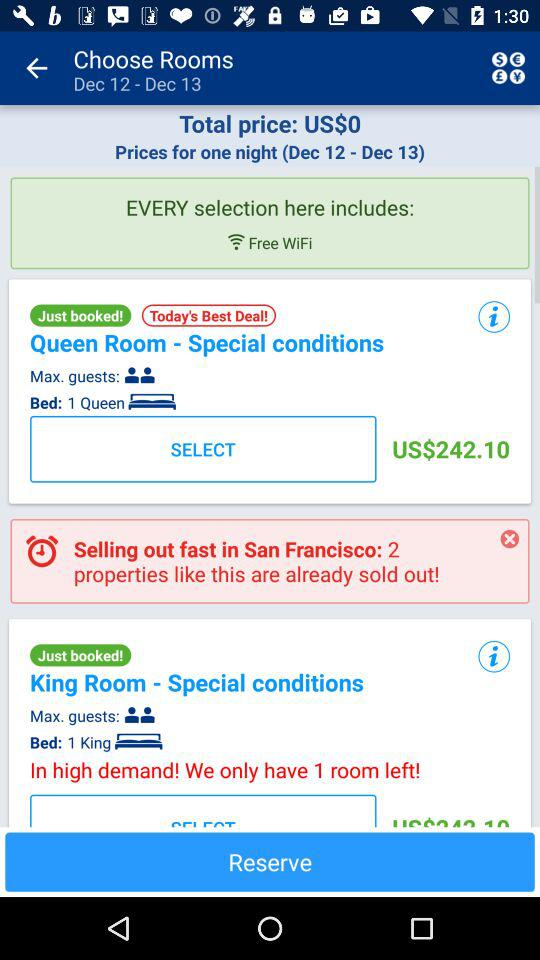What is the price of the queen room? The price of the queen room is USD 242.10. 